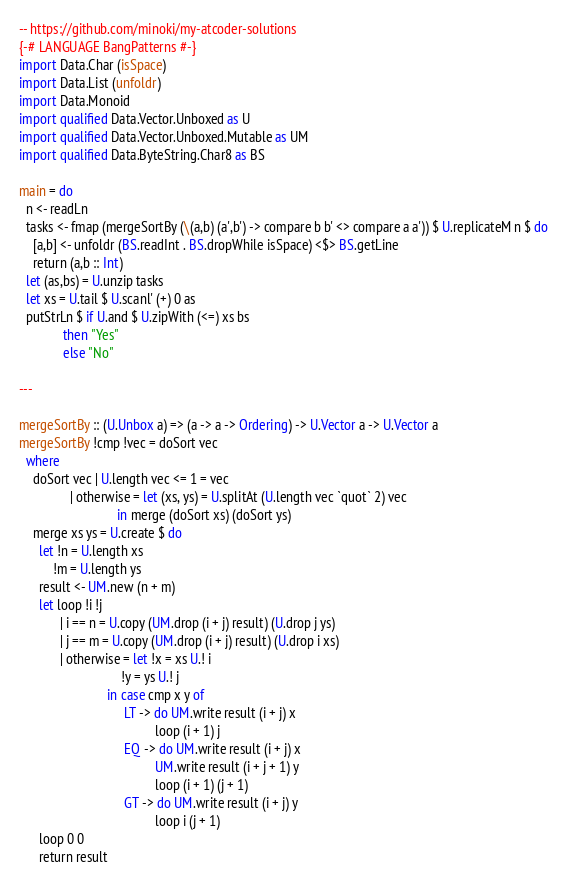<code> <loc_0><loc_0><loc_500><loc_500><_Haskell_>-- https://github.com/minoki/my-atcoder-solutions
{-# LANGUAGE BangPatterns #-}
import Data.Char (isSpace)
import Data.List (unfoldr)
import Data.Monoid
import qualified Data.Vector.Unboxed as U
import qualified Data.Vector.Unboxed.Mutable as UM
import qualified Data.ByteString.Char8 as BS

main = do
  n <- readLn
  tasks <- fmap (mergeSortBy (\(a,b) (a',b') -> compare b b' <> compare a a')) $ U.replicateM n $ do
    [a,b] <- unfoldr (BS.readInt . BS.dropWhile isSpace) <$> BS.getLine
    return (a,b :: Int)
  let (as,bs) = U.unzip tasks
  let xs = U.tail $ U.scanl' (+) 0 as
  putStrLn $ if U.and $ U.zipWith (<=) xs bs
             then "Yes"
             else "No"

---

mergeSortBy :: (U.Unbox a) => (a -> a -> Ordering) -> U.Vector a -> U.Vector a
mergeSortBy !cmp !vec = doSort vec
  where
    doSort vec | U.length vec <= 1 = vec
               | otherwise = let (xs, ys) = U.splitAt (U.length vec `quot` 2) vec
                             in merge (doSort xs) (doSort ys)
    merge xs ys = U.create $ do
      let !n = U.length xs
          !m = U.length ys
      result <- UM.new (n + m)
      let loop !i !j
            | i == n = U.copy (UM.drop (i + j) result) (U.drop j ys)
            | j == m = U.copy (UM.drop (i + j) result) (U.drop i xs)
            | otherwise = let !x = xs U.! i
                              !y = ys U.! j
                          in case cmp x y of
                               LT -> do UM.write result (i + j) x
                                        loop (i + 1) j
                               EQ -> do UM.write result (i + j) x
                                        UM.write result (i + j + 1) y
                                        loop (i + 1) (j + 1)
                               GT -> do UM.write result (i + j) y
                                        loop i (j + 1)
      loop 0 0
      return result
</code> 